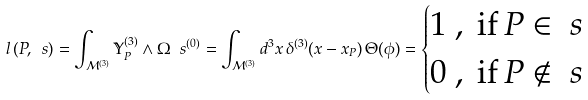<formula> <loc_0><loc_0><loc_500><loc_500>l \left ( P , \ s \right ) = \int _ { \mathcal { M } ^ { ( 3 ) } } \mathbb { Y } _ { P } ^ { ( 3 ) } \wedge \Omega _ { \ } s ^ { ( 0 ) } = \int _ { \mathcal { M } ^ { ( 3 ) } } d ^ { 3 } x \, \delta ^ { ( 3 ) } ( x - x _ { P } ) \, \Theta ( \phi ) = \begin{cases} 1 \ , \ \text {if} \, P \in \ s \\ 0 \ , \ \text {if} \, P \notin \ s \end{cases}</formula> 